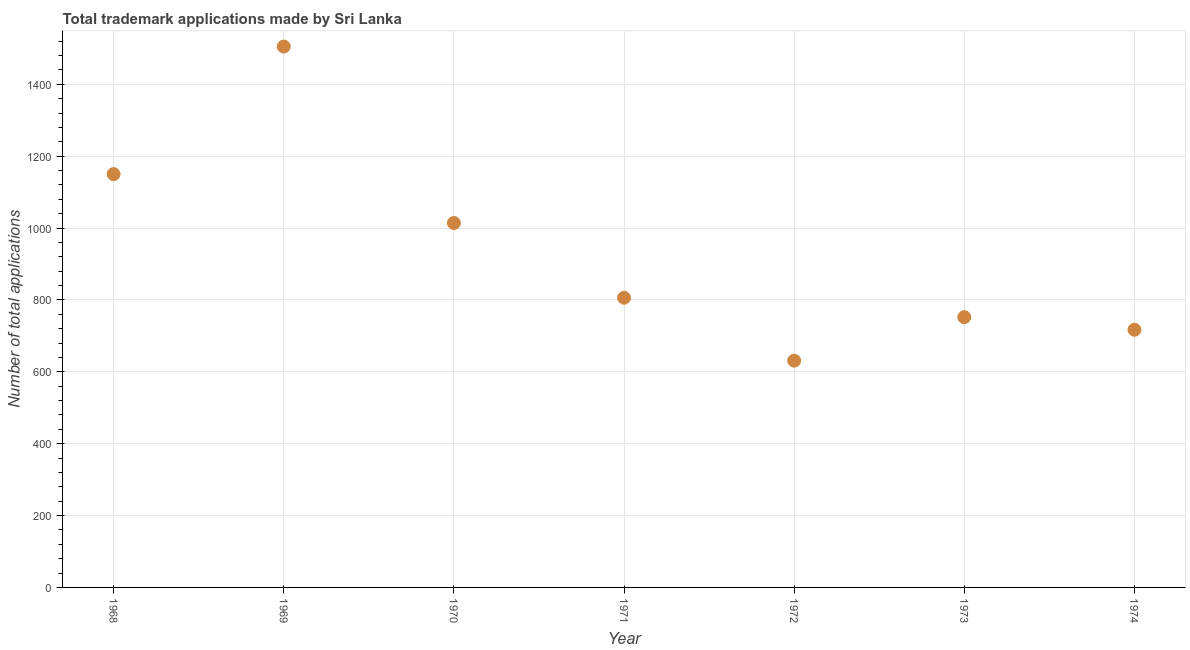What is the number of trademark applications in 1969?
Provide a short and direct response. 1505. Across all years, what is the maximum number of trademark applications?
Keep it short and to the point. 1505. Across all years, what is the minimum number of trademark applications?
Your response must be concise. 631. In which year was the number of trademark applications maximum?
Offer a very short reply. 1969. What is the sum of the number of trademark applications?
Provide a short and direct response. 6575. What is the difference between the number of trademark applications in 1973 and 1974?
Provide a short and direct response. 35. What is the average number of trademark applications per year?
Give a very brief answer. 939.29. What is the median number of trademark applications?
Offer a very short reply. 806. What is the ratio of the number of trademark applications in 1971 to that in 1974?
Make the answer very short. 1.12. Is the difference between the number of trademark applications in 1968 and 1971 greater than the difference between any two years?
Make the answer very short. No. What is the difference between the highest and the second highest number of trademark applications?
Offer a very short reply. 355. Is the sum of the number of trademark applications in 1971 and 1973 greater than the maximum number of trademark applications across all years?
Keep it short and to the point. Yes. What is the difference between the highest and the lowest number of trademark applications?
Give a very brief answer. 874. Does the number of trademark applications monotonically increase over the years?
Offer a very short reply. No. How many dotlines are there?
Ensure brevity in your answer.  1. What is the difference between two consecutive major ticks on the Y-axis?
Provide a short and direct response. 200. Does the graph contain any zero values?
Your response must be concise. No. What is the title of the graph?
Your answer should be very brief. Total trademark applications made by Sri Lanka. What is the label or title of the Y-axis?
Offer a terse response. Number of total applications. What is the Number of total applications in 1968?
Ensure brevity in your answer.  1150. What is the Number of total applications in 1969?
Keep it short and to the point. 1505. What is the Number of total applications in 1970?
Your answer should be very brief. 1014. What is the Number of total applications in 1971?
Your response must be concise. 806. What is the Number of total applications in 1972?
Provide a short and direct response. 631. What is the Number of total applications in 1973?
Make the answer very short. 752. What is the Number of total applications in 1974?
Provide a succinct answer. 717. What is the difference between the Number of total applications in 1968 and 1969?
Provide a succinct answer. -355. What is the difference between the Number of total applications in 1968 and 1970?
Your answer should be very brief. 136. What is the difference between the Number of total applications in 1968 and 1971?
Make the answer very short. 344. What is the difference between the Number of total applications in 1968 and 1972?
Make the answer very short. 519. What is the difference between the Number of total applications in 1968 and 1973?
Offer a terse response. 398. What is the difference between the Number of total applications in 1968 and 1974?
Give a very brief answer. 433. What is the difference between the Number of total applications in 1969 and 1970?
Ensure brevity in your answer.  491. What is the difference between the Number of total applications in 1969 and 1971?
Offer a terse response. 699. What is the difference between the Number of total applications in 1969 and 1972?
Give a very brief answer. 874. What is the difference between the Number of total applications in 1969 and 1973?
Provide a short and direct response. 753. What is the difference between the Number of total applications in 1969 and 1974?
Make the answer very short. 788. What is the difference between the Number of total applications in 1970 and 1971?
Provide a short and direct response. 208. What is the difference between the Number of total applications in 1970 and 1972?
Your answer should be compact. 383. What is the difference between the Number of total applications in 1970 and 1973?
Ensure brevity in your answer.  262. What is the difference between the Number of total applications in 1970 and 1974?
Offer a very short reply. 297. What is the difference between the Number of total applications in 1971 and 1972?
Make the answer very short. 175. What is the difference between the Number of total applications in 1971 and 1974?
Ensure brevity in your answer.  89. What is the difference between the Number of total applications in 1972 and 1973?
Make the answer very short. -121. What is the difference between the Number of total applications in 1972 and 1974?
Your answer should be very brief. -86. What is the difference between the Number of total applications in 1973 and 1974?
Your response must be concise. 35. What is the ratio of the Number of total applications in 1968 to that in 1969?
Give a very brief answer. 0.76. What is the ratio of the Number of total applications in 1968 to that in 1970?
Provide a short and direct response. 1.13. What is the ratio of the Number of total applications in 1968 to that in 1971?
Ensure brevity in your answer.  1.43. What is the ratio of the Number of total applications in 1968 to that in 1972?
Ensure brevity in your answer.  1.82. What is the ratio of the Number of total applications in 1968 to that in 1973?
Offer a very short reply. 1.53. What is the ratio of the Number of total applications in 1968 to that in 1974?
Ensure brevity in your answer.  1.6. What is the ratio of the Number of total applications in 1969 to that in 1970?
Offer a terse response. 1.48. What is the ratio of the Number of total applications in 1969 to that in 1971?
Make the answer very short. 1.87. What is the ratio of the Number of total applications in 1969 to that in 1972?
Make the answer very short. 2.38. What is the ratio of the Number of total applications in 1969 to that in 1973?
Your answer should be compact. 2. What is the ratio of the Number of total applications in 1969 to that in 1974?
Keep it short and to the point. 2.1. What is the ratio of the Number of total applications in 1970 to that in 1971?
Your answer should be compact. 1.26. What is the ratio of the Number of total applications in 1970 to that in 1972?
Provide a short and direct response. 1.61. What is the ratio of the Number of total applications in 1970 to that in 1973?
Give a very brief answer. 1.35. What is the ratio of the Number of total applications in 1970 to that in 1974?
Your answer should be compact. 1.41. What is the ratio of the Number of total applications in 1971 to that in 1972?
Your response must be concise. 1.28. What is the ratio of the Number of total applications in 1971 to that in 1973?
Your response must be concise. 1.07. What is the ratio of the Number of total applications in 1971 to that in 1974?
Provide a succinct answer. 1.12. What is the ratio of the Number of total applications in 1972 to that in 1973?
Offer a terse response. 0.84. What is the ratio of the Number of total applications in 1973 to that in 1974?
Your answer should be compact. 1.05. 